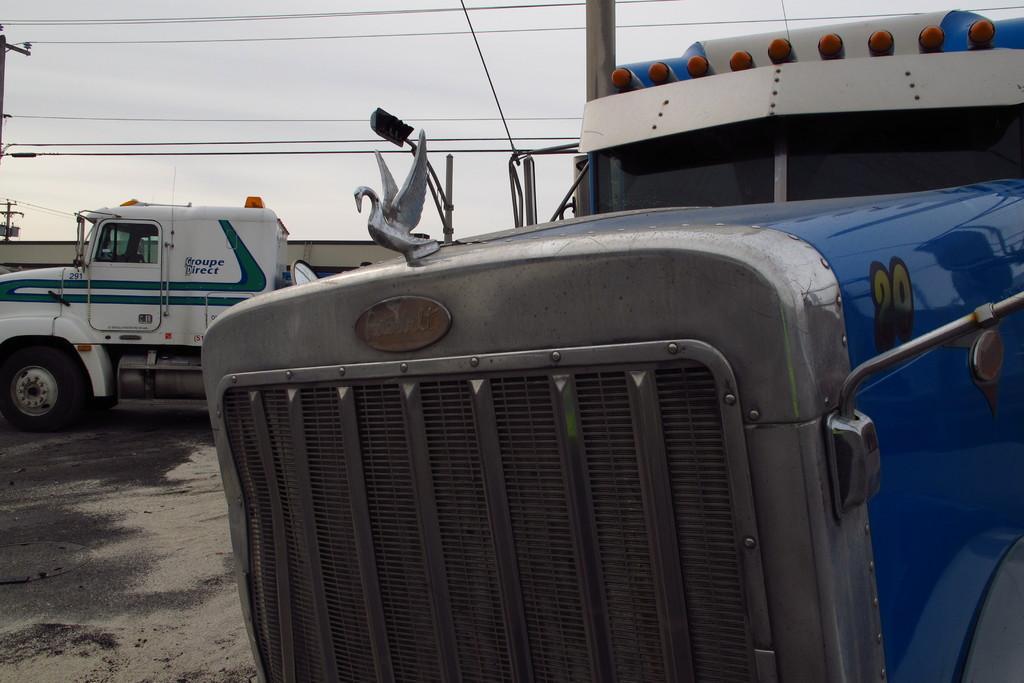Describe this image in one or two sentences. In this picture i can see vehicles on the ground. On the left side i can see pokes on which wires are attached. In the background i can see sky. 